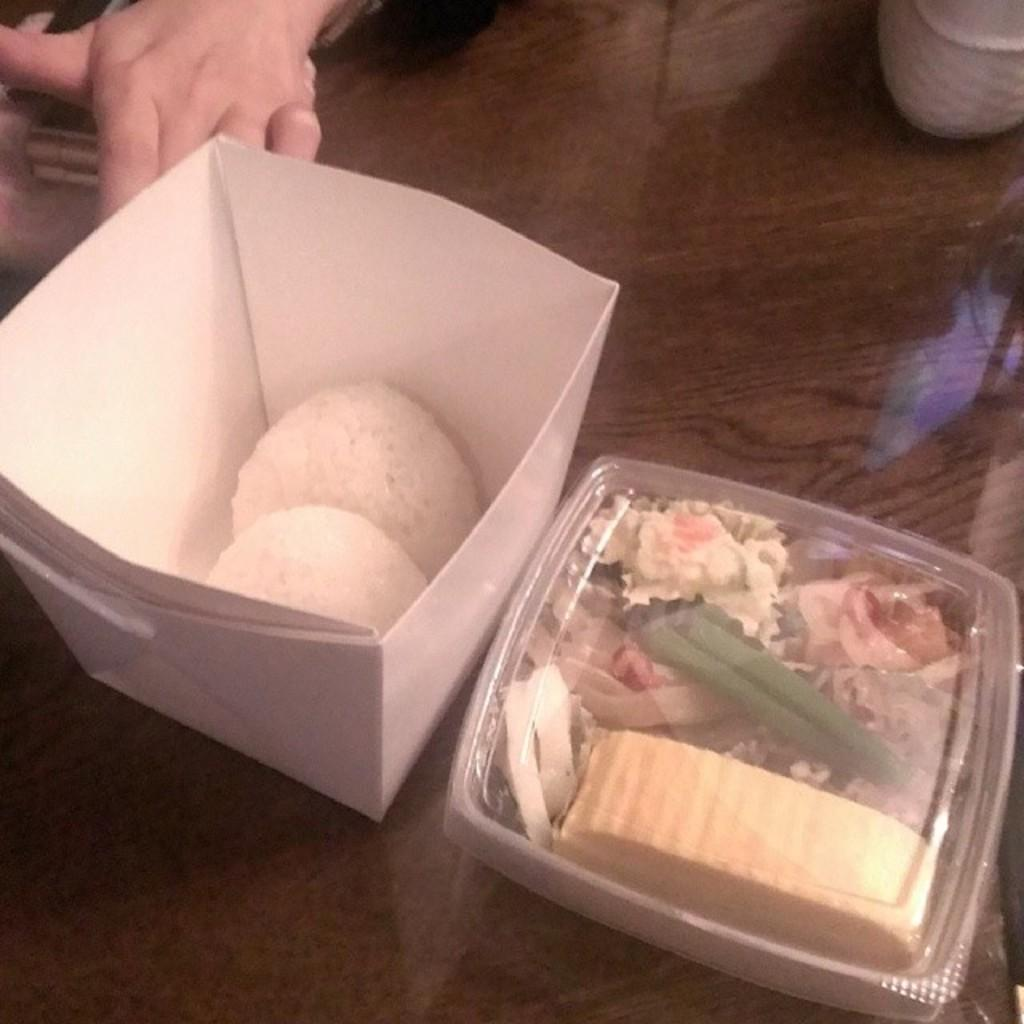What is on the table in the image? There are food items in boxes on a table. Can you describe any other details about the table or its contents? There is a person's hand on the left side of the image. What type of blade is being used to cut the meat in the image? There is no meat or blade present in the image; it only shows food items in boxes on a table and a person's hand. 